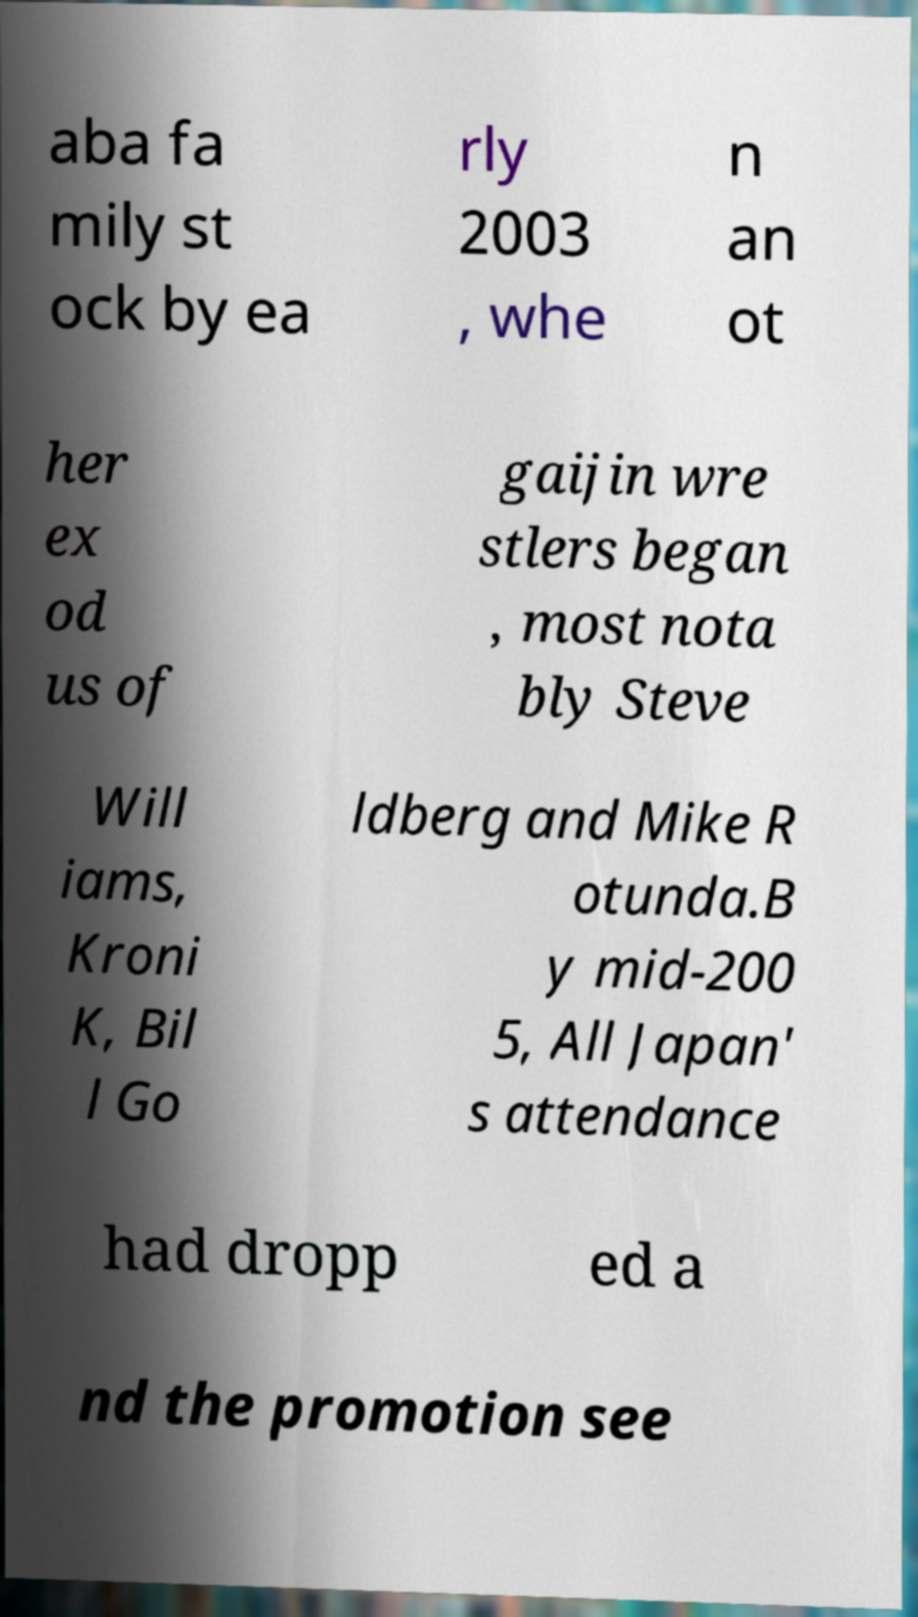There's text embedded in this image that I need extracted. Can you transcribe it verbatim? aba fa mily st ock by ea rly 2003 , whe n an ot her ex od us of gaijin wre stlers began , most nota bly Steve Will iams, Kroni K, Bil l Go ldberg and Mike R otunda.B y mid-200 5, All Japan' s attendance had dropp ed a nd the promotion see 